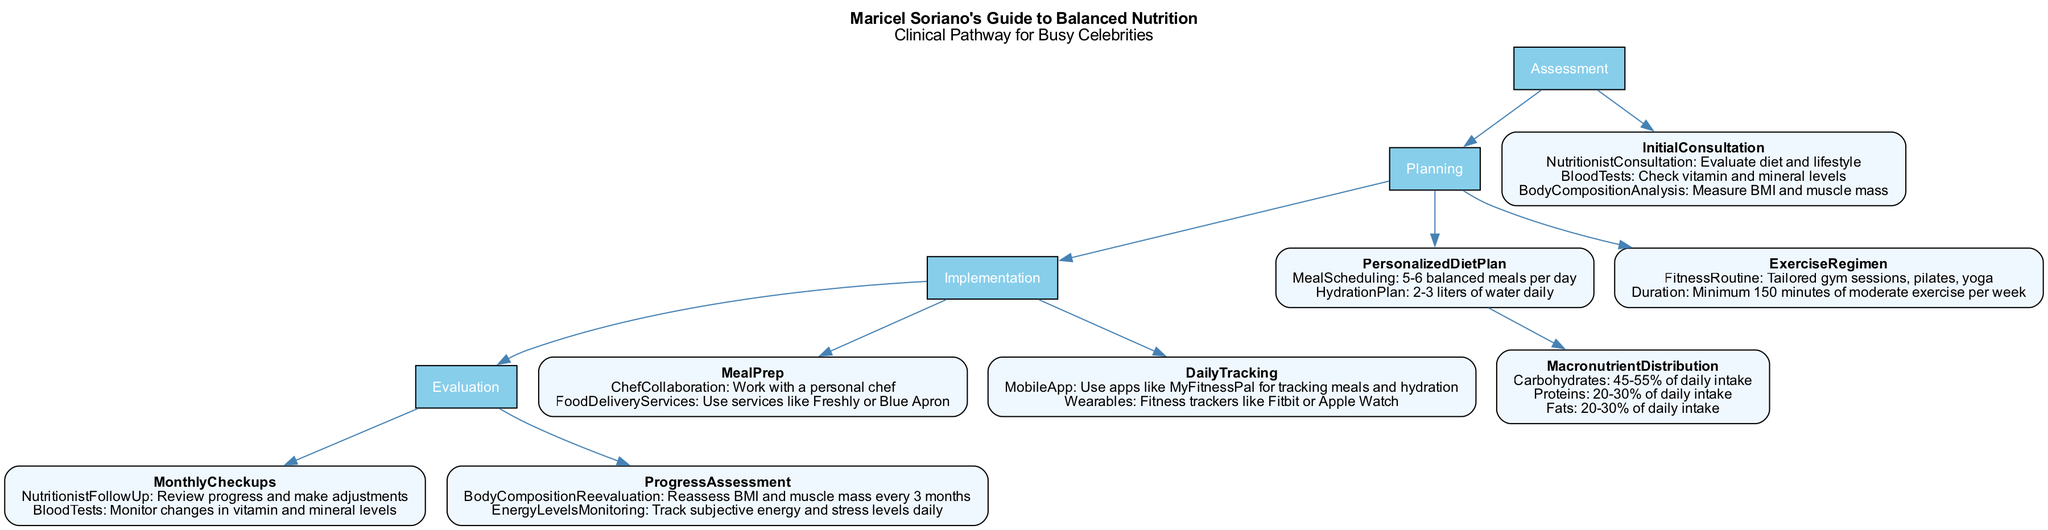What is the main title of the clinical pathway? The diagram clearly states that the main title of the clinical pathway is "Maricel Soriano's Guide to Balanced Nutrition".
Answer: Maricel Soriano's Guide to Balanced Nutrition How many main sections are in the clinical pathway? By counting the nodes labeled as main sections, we see there are four sections: Assessment, Planning, Implementation, and Evaluation.
Answer: 4 What percentage of daily intake should carbohydrates comprise? The diagram specifies that carbohydrates should make up 45-55% of daily intake according to the macronutrient distribution section.
Answer: 45-55% Which professional is involved in the initial consultation? The diagram indicates that a nutritionist is the professional conducting the initial consultation.
Answer: Nutritionist What is the purpose of the monthly checkups? The evaluation section mentions that monthly checkups aim to review progress and make adjustments with nutritionist follow-up and monitor blood test changes.
Answer: Review progress and monitor changes What type of exercise is included in the regimen? The fitness regimen includes various types, explicitly mentioning tailored gym sessions, pilates, and yoga for exercise.
Answer: Tailored gym sessions, pilates, yoga How many meals are suggested to be scheduled per day? The meal scheduling node indicates that 5-6 balanced meals should be consumed each day according to the personalized diet plan.
Answer: 5-6 What is tracked daily according to the evaluation section? The evaluation section includes energy levels monitoring, which tracks subjective energy and stress levels every day.
Answer: Energy levels monitoring What is the recommended hydration plan? The hydration plan recommends consuming 2-3 liters of water daily as per the planning section of the diagram.
Answer: 2-3 liters of water daily 